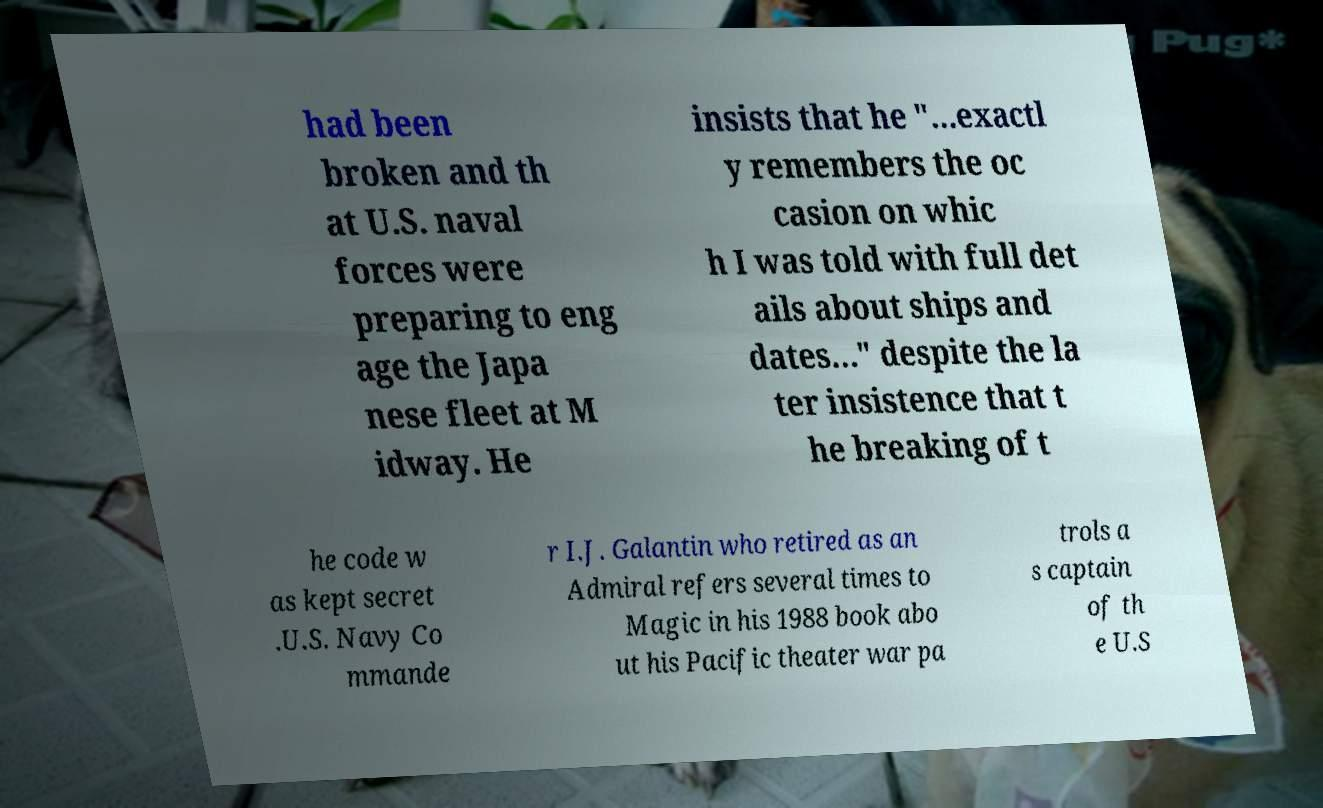For documentation purposes, I need the text within this image transcribed. Could you provide that? had been broken and th at U.S. naval forces were preparing to eng age the Japa nese fleet at M idway. He insists that he "…exactl y remembers the oc casion on whic h I was told with full det ails about ships and dates…" despite the la ter insistence that t he breaking of t he code w as kept secret .U.S. Navy Co mmande r I.J. Galantin who retired as an Admiral refers several times to Magic in his 1988 book abo ut his Pacific theater war pa trols a s captain of th e U.S 